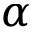Convert formula to latex. <formula><loc_0><loc_0><loc_500><loc_500>\alpha</formula> 